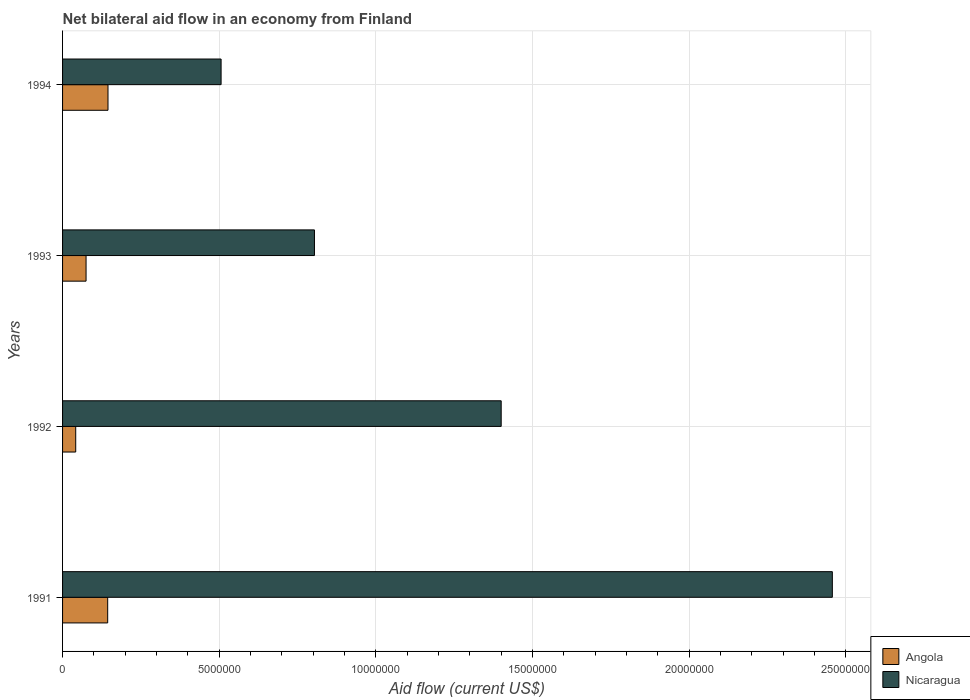What is the label of the 3rd group of bars from the top?
Make the answer very short. 1992. What is the net bilateral aid flow in Angola in 1992?
Your answer should be very brief. 4.20e+05. Across all years, what is the maximum net bilateral aid flow in Angola?
Make the answer very short. 1.45e+06. In which year was the net bilateral aid flow in Nicaragua maximum?
Provide a succinct answer. 1991. What is the total net bilateral aid flow in Nicaragua in the graph?
Offer a very short reply. 5.17e+07. What is the difference between the net bilateral aid flow in Nicaragua in 1991 and that in 1994?
Your answer should be very brief. 1.95e+07. What is the difference between the net bilateral aid flow in Angola in 1992 and the net bilateral aid flow in Nicaragua in 1991?
Your answer should be compact. -2.42e+07. What is the average net bilateral aid flow in Nicaragua per year?
Ensure brevity in your answer.  1.29e+07. In the year 1992, what is the difference between the net bilateral aid flow in Nicaragua and net bilateral aid flow in Angola?
Offer a terse response. 1.36e+07. In how many years, is the net bilateral aid flow in Nicaragua greater than 14000000 US$?
Your response must be concise. 1. What is the ratio of the net bilateral aid flow in Angola in 1991 to that in 1993?
Keep it short and to the point. 1.92. Is the net bilateral aid flow in Nicaragua in 1993 less than that in 1994?
Give a very brief answer. No. What is the difference between the highest and the second highest net bilateral aid flow in Nicaragua?
Provide a succinct answer. 1.06e+07. What is the difference between the highest and the lowest net bilateral aid flow in Nicaragua?
Keep it short and to the point. 1.95e+07. Is the sum of the net bilateral aid flow in Angola in 1992 and 1994 greater than the maximum net bilateral aid flow in Nicaragua across all years?
Make the answer very short. No. What does the 1st bar from the top in 1992 represents?
Provide a short and direct response. Nicaragua. What does the 2nd bar from the bottom in 1991 represents?
Your response must be concise. Nicaragua. How many bars are there?
Your response must be concise. 8. Are all the bars in the graph horizontal?
Offer a very short reply. Yes. Are the values on the major ticks of X-axis written in scientific E-notation?
Your answer should be very brief. No. How are the legend labels stacked?
Ensure brevity in your answer.  Vertical. What is the title of the graph?
Offer a terse response. Net bilateral aid flow in an economy from Finland. What is the Aid flow (current US$) in Angola in 1991?
Your response must be concise. 1.44e+06. What is the Aid flow (current US$) of Nicaragua in 1991?
Your response must be concise. 2.46e+07. What is the Aid flow (current US$) in Nicaragua in 1992?
Ensure brevity in your answer.  1.40e+07. What is the Aid flow (current US$) of Angola in 1993?
Your response must be concise. 7.50e+05. What is the Aid flow (current US$) of Nicaragua in 1993?
Offer a terse response. 8.04e+06. What is the Aid flow (current US$) in Angola in 1994?
Your response must be concise. 1.45e+06. What is the Aid flow (current US$) in Nicaragua in 1994?
Keep it short and to the point. 5.06e+06. Across all years, what is the maximum Aid flow (current US$) in Angola?
Your response must be concise. 1.45e+06. Across all years, what is the maximum Aid flow (current US$) of Nicaragua?
Offer a terse response. 2.46e+07. Across all years, what is the minimum Aid flow (current US$) in Nicaragua?
Offer a terse response. 5.06e+06. What is the total Aid flow (current US$) in Angola in the graph?
Your answer should be compact. 4.06e+06. What is the total Aid flow (current US$) of Nicaragua in the graph?
Your answer should be very brief. 5.17e+07. What is the difference between the Aid flow (current US$) in Angola in 1991 and that in 1992?
Your answer should be compact. 1.02e+06. What is the difference between the Aid flow (current US$) of Nicaragua in 1991 and that in 1992?
Your answer should be compact. 1.06e+07. What is the difference between the Aid flow (current US$) in Angola in 1991 and that in 1993?
Ensure brevity in your answer.  6.90e+05. What is the difference between the Aid flow (current US$) of Nicaragua in 1991 and that in 1993?
Provide a succinct answer. 1.65e+07. What is the difference between the Aid flow (current US$) in Angola in 1991 and that in 1994?
Ensure brevity in your answer.  -10000. What is the difference between the Aid flow (current US$) of Nicaragua in 1991 and that in 1994?
Make the answer very short. 1.95e+07. What is the difference between the Aid flow (current US$) in Angola in 1992 and that in 1993?
Your answer should be very brief. -3.30e+05. What is the difference between the Aid flow (current US$) in Nicaragua in 1992 and that in 1993?
Make the answer very short. 5.96e+06. What is the difference between the Aid flow (current US$) in Angola in 1992 and that in 1994?
Your answer should be compact. -1.03e+06. What is the difference between the Aid flow (current US$) of Nicaragua in 1992 and that in 1994?
Keep it short and to the point. 8.94e+06. What is the difference between the Aid flow (current US$) of Angola in 1993 and that in 1994?
Your answer should be very brief. -7.00e+05. What is the difference between the Aid flow (current US$) in Nicaragua in 1993 and that in 1994?
Provide a succinct answer. 2.98e+06. What is the difference between the Aid flow (current US$) in Angola in 1991 and the Aid flow (current US$) in Nicaragua in 1992?
Offer a very short reply. -1.26e+07. What is the difference between the Aid flow (current US$) of Angola in 1991 and the Aid flow (current US$) of Nicaragua in 1993?
Ensure brevity in your answer.  -6.60e+06. What is the difference between the Aid flow (current US$) in Angola in 1991 and the Aid flow (current US$) in Nicaragua in 1994?
Provide a succinct answer. -3.62e+06. What is the difference between the Aid flow (current US$) in Angola in 1992 and the Aid flow (current US$) in Nicaragua in 1993?
Make the answer very short. -7.62e+06. What is the difference between the Aid flow (current US$) of Angola in 1992 and the Aid flow (current US$) of Nicaragua in 1994?
Your answer should be very brief. -4.64e+06. What is the difference between the Aid flow (current US$) of Angola in 1993 and the Aid flow (current US$) of Nicaragua in 1994?
Your response must be concise. -4.31e+06. What is the average Aid flow (current US$) in Angola per year?
Give a very brief answer. 1.02e+06. What is the average Aid flow (current US$) in Nicaragua per year?
Offer a very short reply. 1.29e+07. In the year 1991, what is the difference between the Aid flow (current US$) of Angola and Aid flow (current US$) of Nicaragua?
Give a very brief answer. -2.31e+07. In the year 1992, what is the difference between the Aid flow (current US$) of Angola and Aid flow (current US$) of Nicaragua?
Offer a very short reply. -1.36e+07. In the year 1993, what is the difference between the Aid flow (current US$) in Angola and Aid flow (current US$) in Nicaragua?
Offer a very short reply. -7.29e+06. In the year 1994, what is the difference between the Aid flow (current US$) of Angola and Aid flow (current US$) of Nicaragua?
Offer a terse response. -3.61e+06. What is the ratio of the Aid flow (current US$) of Angola in 1991 to that in 1992?
Ensure brevity in your answer.  3.43. What is the ratio of the Aid flow (current US$) of Nicaragua in 1991 to that in 1992?
Keep it short and to the point. 1.75. What is the ratio of the Aid flow (current US$) in Angola in 1991 to that in 1993?
Provide a succinct answer. 1.92. What is the ratio of the Aid flow (current US$) in Nicaragua in 1991 to that in 1993?
Make the answer very short. 3.06. What is the ratio of the Aid flow (current US$) of Nicaragua in 1991 to that in 1994?
Your answer should be compact. 4.86. What is the ratio of the Aid flow (current US$) in Angola in 1992 to that in 1993?
Offer a terse response. 0.56. What is the ratio of the Aid flow (current US$) in Nicaragua in 1992 to that in 1993?
Your response must be concise. 1.74. What is the ratio of the Aid flow (current US$) in Angola in 1992 to that in 1994?
Your answer should be very brief. 0.29. What is the ratio of the Aid flow (current US$) of Nicaragua in 1992 to that in 1994?
Your response must be concise. 2.77. What is the ratio of the Aid flow (current US$) of Angola in 1993 to that in 1994?
Offer a very short reply. 0.52. What is the ratio of the Aid flow (current US$) of Nicaragua in 1993 to that in 1994?
Offer a very short reply. 1.59. What is the difference between the highest and the second highest Aid flow (current US$) of Angola?
Ensure brevity in your answer.  10000. What is the difference between the highest and the second highest Aid flow (current US$) in Nicaragua?
Make the answer very short. 1.06e+07. What is the difference between the highest and the lowest Aid flow (current US$) in Angola?
Make the answer very short. 1.03e+06. What is the difference between the highest and the lowest Aid flow (current US$) in Nicaragua?
Provide a short and direct response. 1.95e+07. 